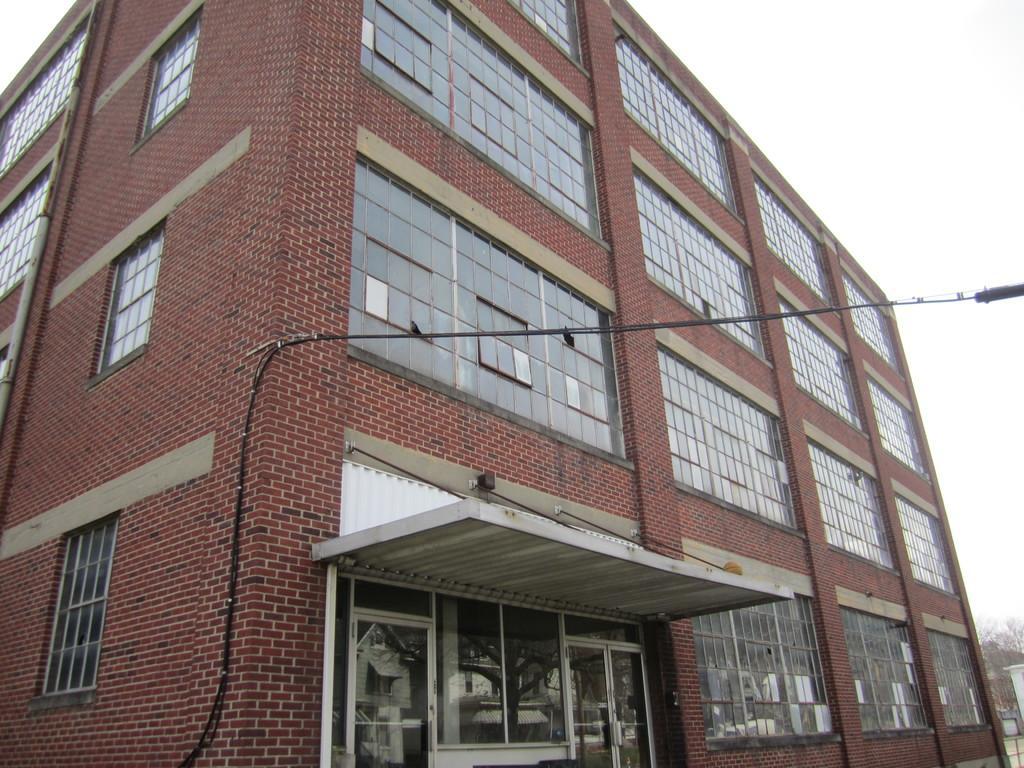In one or two sentences, can you explain what this image depicts? In this picture we can see a building. There are a few windows, wires and glasses are visible on this building. We can see the reflection of a tree and a house on these glasses. There are trees visible on the right side. 